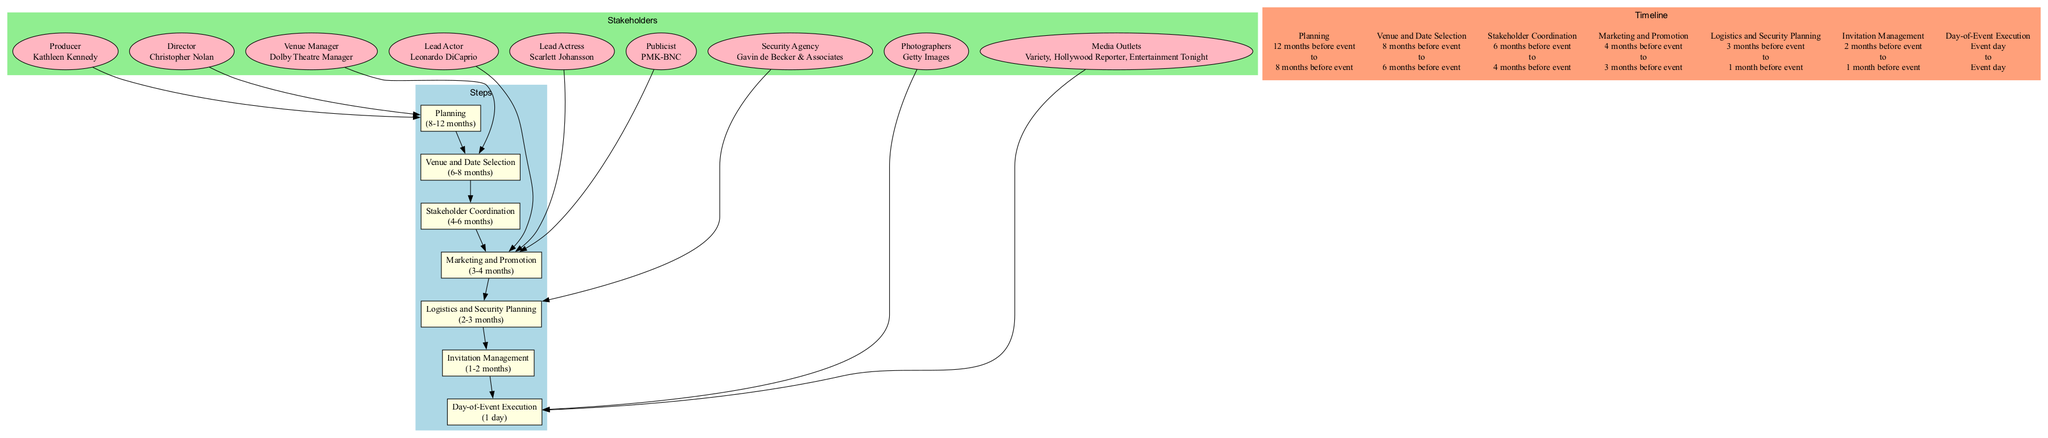What is the duration of the "Marketing and Promotion" step? The "Marketing and Promotion" step is indicated in the diagram with a duration of "3-4 months," which shows the time frame designated for this phase in planning the movie premiere.
Answer: 3-4 months Who is listed as the Lead Actor? In the diagram, one of the stakeholders is identified as the Lead Actor, specifically listed as "Leonardo DiCaprio," highlighting his role in the movie premiere event.
Answer: Leonardo DiCaprio How many steps are outlined in the diagram? The diagram features a total of seven steps sequentially listed for the movie premiere event, representing each stage of coordination and planning.
Answer: 7 What is the relationship between the "Security Agency" and "Logistics and Security Planning"? The diagram shows a directed edge connecting the "Security Agency" node to the "Logistics and Security Planning" step, indicating that the Security Agency plays an essential role in planning for the logistics and security aspects of the event.
Answer: Logistics and Security Planning Which stakeholders are involved in the "Marketing and Promotion"? The diagram connects several stakeholders, including "Lead Actor," "Lead Actress," and "Publicist," to the "Marketing and Promotion" step, indicating their involvement in this phase of the movie premiere event preparation.
Answer: Lead Actor, Lead Actress, Publicist What is the timeline for "Stakeholder Coordination"? According to the diagram, the "Stakeholder Coordination" step starts 6 months before the event and ends 4 months before the event, outlining the specific timeframe for coordinating with various stakeholders.
Answer: 6 months before event to 4 months before event What is the final step in the sequence of the diagram? The last node in the order of operations outlined in the diagram is "Day-of-Event Execution," indicating it's the culmination of all previous steps, concluding the planning process on the event day itself.
Answer: Day-of-Event Execution Which stakeholder manages the venue selection? The diagram specifically identifies the venue management role as "Dolby Theatre Manager," indicating their responsibility for the venue selection process for the movie premiere.
Answer: Dolby Theatre Manager In total, how many types of stakeholders are represented in the diagram? The diagram cleverly categorizes stakeholders into various roles such as Director, Producer, Lead Actor, Lead Actress, Publicist, Security Agency, Venue Manager, Photographers, and Media Outlets, which sums up to a total of eight different stakeholder types involved in the movie premiere.
Answer: 8 